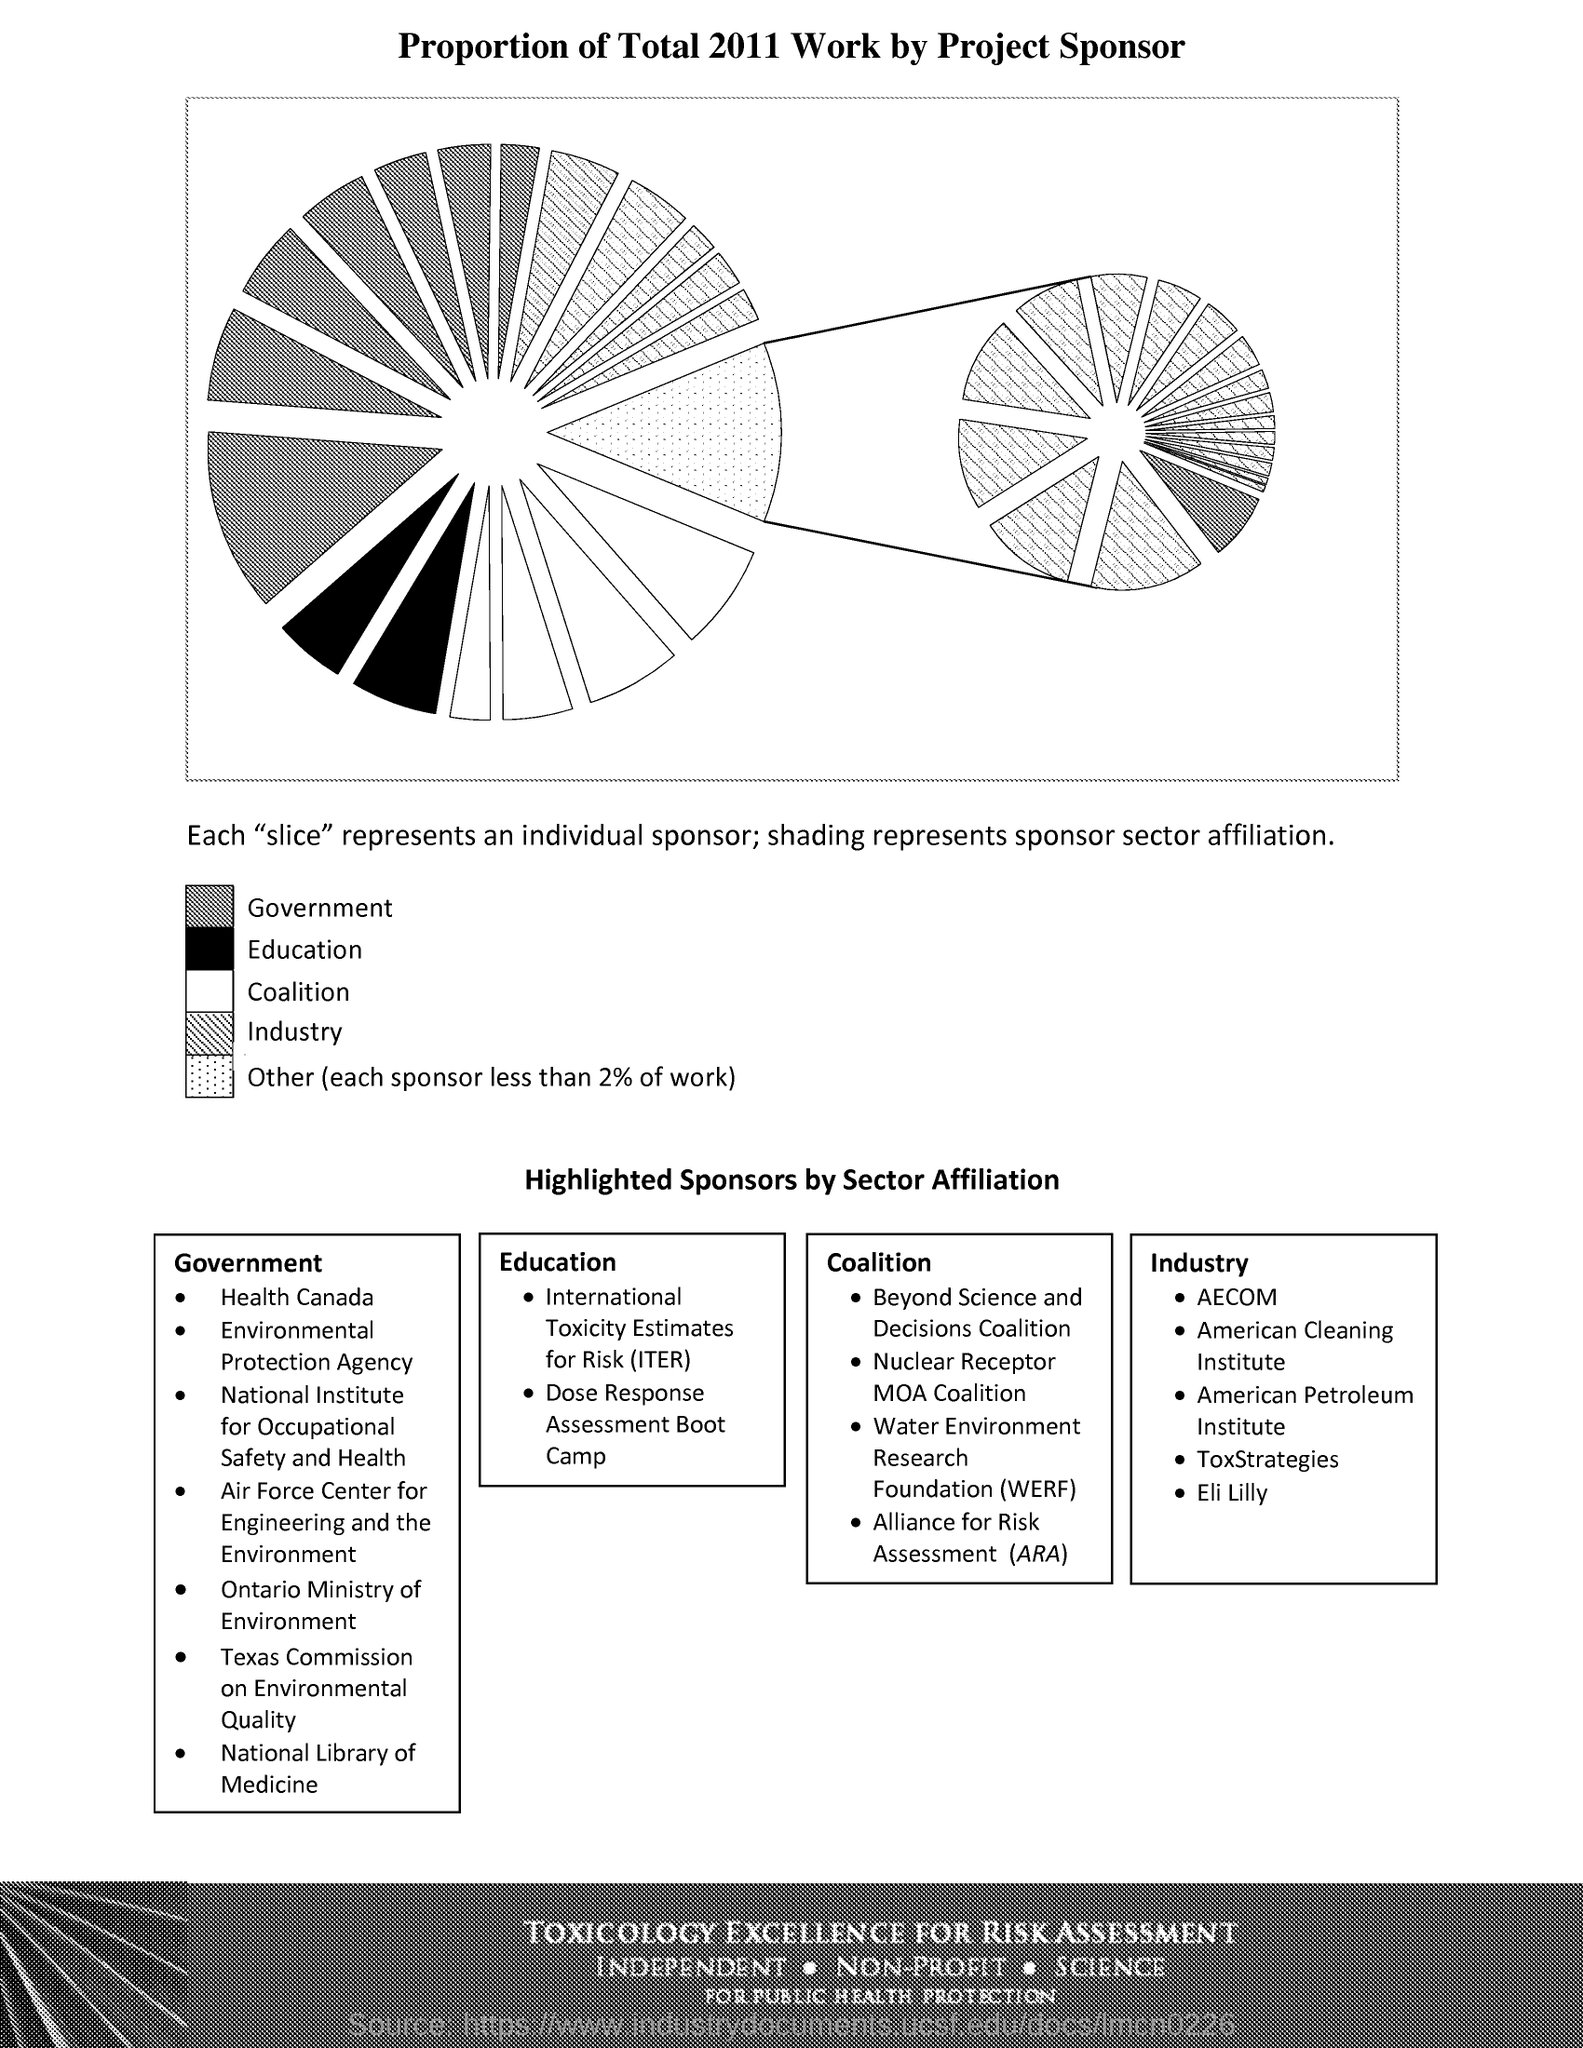What does each "slice" represent?
Your answer should be compact. An Individual Sponsor. What does the shading represent?
Provide a succinct answer. Sponsor sector affiliation. What does ARA stand for?
Your answer should be very brief. Alliance for Risk Assessment. What does WERF stand for?
Your answer should be very brief. Water Environment Research Foundation. 